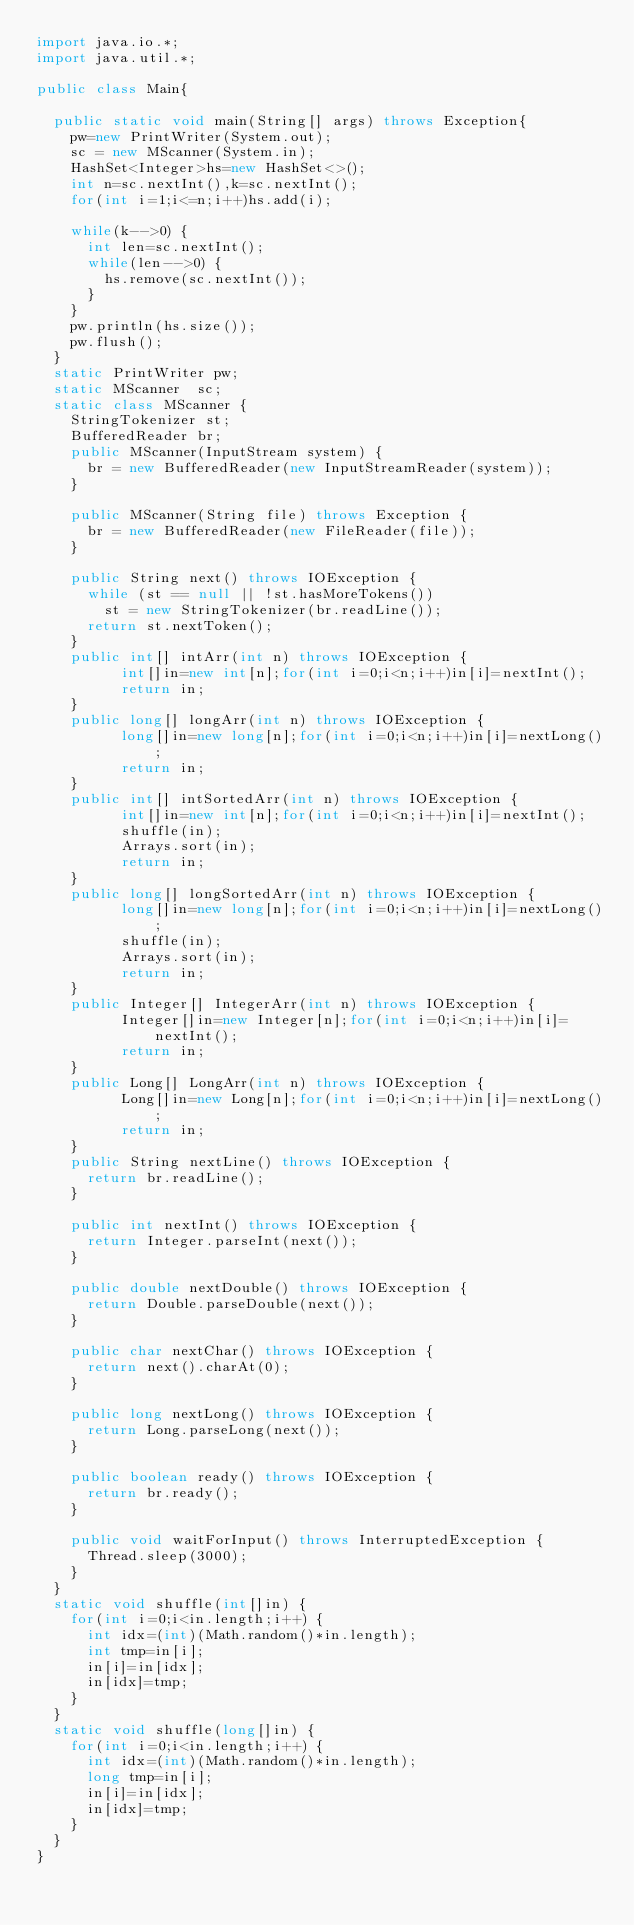<code> <loc_0><loc_0><loc_500><loc_500><_Java_>import java.io.*;
import java.util.*;

public class Main{
	
	public static void main(String[] args) throws Exception{
		pw=new PrintWriter(System.out);
		sc = new MScanner(System.in);
		HashSet<Integer>hs=new HashSet<>();
		int n=sc.nextInt(),k=sc.nextInt();
		for(int i=1;i<=n;i++)hs.add(i);
		
		while(k-->0) {
			int len=sc.nextInt();
			while(len-->0) {
				hs.remove(sc.nextInt());
			}
		}
		pw.println(hs.size());
		pw.flush();
	}
	static PrintWriter pw;
	static MScanner  sc;
	static class MScanner {
		StringTokenizer st;
		BufferedReader br;
		public MScanner(InputStream system) {
			br = new BufferedReader(new InputStreamReader(system));
		}
 
		public MScanner(String file) throws Exception {
			br = new BufferedReader(new FileReader(file));
		}
 
		public String next() throws IOException {
			while (st == null || !st.hasMoreTokens())
				st = new StringTokenizer(br.readLine());
			return st.nextToken();
		}
		public int[] intArr(int n) throws IOException {
	        int[]in=new int[n];for(int i=0;i<n;i++)in[i]=nextInt();
	        return in;
		}
		public long[] longArr(int n) throws IOException {
	        long[]in=new long[n];for(int i=0;i<n;i++)in[i]=nextLong();
	        return in;
		}
		public int[] intSortedArr(int n) throws IOException {
	        int[]in=new int[n];for(int i=0;i<n;i++)in[i]=nextInt();
	        shuffle(in);
	        Arrays.sort(in);
	        return in;
		}
		public long[] longSortedArr(int n) throws IOException {
	        long[]in=new long[n];for(int i=0;i<n;i++)in[i]=nextLong();
	        shuffle(in);
	        Arrays.sort(in);
	        return in;
		}
		public Integer[] IntegerArr(int n) throws IOException {
	        Integer[]in=new Integer[n];for(int i=0;i<n;i++)in[i]=nextInt();
	        return in;
		}
		public Long[] LongArr(int n) throws IOException {
	        Long[]in=new Long[n];for(int i=0;i<n;i++)in[i]=nextLong();
	        return in;
		}
		public String nextLine() throws IOException {
			return br.readLine();
		}
 
		public int nextInt() throws IOException {
			return Integer.parseInt(next());
		}
 
		public double nextDouble() throws IOException {
			return Double.parseDouble(next());
		}
 
		public char nextChar() throws IOException {
			return next().charAt(0);
		}
 
		public long nextLong() throws IOException {
			return Long.parseLong(next());
		}
 
		public boolean ready() throws IOException {
			return br.ready();
		}
 
		public void waitForInput() throws InterruptedException {
			Thread.sleep(3000);
		}
	}
	static void shuffle(int[]in) {
		for(int i=0;i<in.length;i++) {
			int idx=(int)(Math.random()*in.length);
			int tmp=in[i];
			in[i]=in[idx];
			in[idx]=tmp;
		}
	}
	static void shuffle(long[]in) {
		for(int i=0;i<in.length;i++) {
			int idx=(int)(Math.random()*in.length);
			long tmp=in[i];
			in[i]=in[idx];
			in[idx]=tmp;
		}
	}
}
</code> 